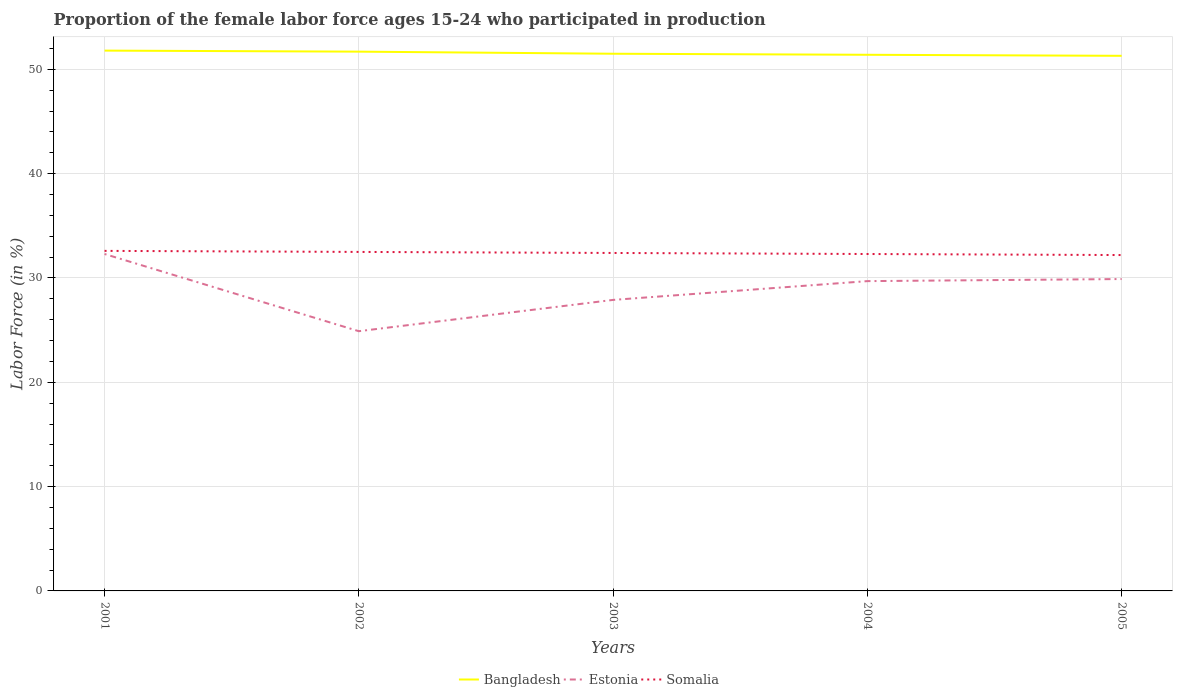How many different coloured lines are there?
Give a very brief answer. 3. Does the line corresponding to Somalia intersect with the line corresponding to Estonia?
Offer a very short reply. No. Across all years, what is the maximum proportion of the female labor force who participated in production in Bangladesh?
Provide a short and direct response. 51.3. What is the total proportion of the female labor force who participated in production in Somalia in the graph?
Make the answer very short. 0.1. What is the difference between the highest and the second highest proportion of the female labor force who participated in production in Estonia?
Provide a succinct answer. 7.4. What is the difference between two consecutive major ticks on the Y-axis?
Keep it short and to the point. 10. Are the values on the major ticks of Y-axis written in scientific E-notation?
Your response must be concise. No. Does the graph contain grids?
Your answer should be very brief. Yes. Where does the legend appear in the graph?
Make the answer very short. Bottom center. How many legend labels are there?
Give a very brief answer. 3. How are the legend labels stacked?
Offer a very short reply. Horizontal. What is the title of the graph?
Your answer should be very brief. Proportion of the female labor force ages 15-24 who participated in production. Does "Liberia" appear as one of the legend labels in the graph?
Your response must be concise. No. What is the label or title of the X-axis?
Make the answer very short. Years. What is the label or title of the Y-axis?
Offer a terse response. Labor Force (in %). What is the Labor Force (in %) of Bangladesh in 2001?
Offer a very short reply. 51.8. What is the Labor Force (in %) of Estonia in 2001?
Give a very brief answer. 32.3. What is the Labor Force (in %) in Somalia in 2001?
Make the answer very short. 32.6. What is the Labor Force (in %) of Bangladesh in 2002?
Ensure brevity in your answer.  51.7. What is the Labor Force (in %) in Estonia in 2002?
Your answer should be compact. 24.9. What is the Labor Force (in %) in Somalia in 2002?
Your response must be concise. 32.5. What is the Labor Force (in %) of Bangladesh in 2003?
Offer a terse response. 51.5. What is the Labor Force (in %) in Estonia in 2003?
Give a very brief answer. 27.9. What is the Labor Force (in %) of Somalia in 2003?
Offer a terse response. 32.4. What is the Labor Force (in %) in Bangladesh in 2004?
Provide a succinct answer. 51.4. What is the Labor Force (in %) of Estonia in 2004?
Your answer should be very brief. 29.7. What is the Labor Force (in %) in Somalia in 2004?
Give a very brief answer. 32.3. What is the Labor Force (in %) in Bangladesh in 2005?
Offer a very short reply. 51.3. What is the Labor Force (in %) of Estonia in 2005?
Your answer should be compact. 29.9. What is the Labor Force (in %) of Somalia in 2005?
Provide a short and direct response. 32.2. Across all years, what is the maximum Labor Force (in %) in Bangladesh?
Keep it short and to the point. 51.8. Across all years, what is the maximum Labor Force (in %) in Estonia?
Keep it short and to the point. 32.3. Across all years, what is the maximum Labor Force (in %) in Somalia?
Ensure brevity in your answer.  32.6. Across all years, what is the minimum Labor Force (in %) in Bangladesh?
Give a very brief answer. 51.3. Across all years, what is the minimum Labor Force (in %) of Estonia?
Your answer should be very brief. 24.9. Across all years, what is the minimum Labor Force (in %) of Somalia?
Make the answer very short. 32.2. What is the total Labor Force (in %) in Bangladesh in the graph?
Your answer should be compact. 257.7. What is the total Labor Force (in %) in Estonia in the graph?
Offer a terse response. 144.7. What is the total Labor Force (in %) in Somalia in the graph?
Offer a very short reply. 162. What is the difference between the Labor Force (in %) in Bangladesh in 2001 and that in 2002?
Your response must be concise. 0.1. What is the difference between the Labor Force (in %) in Estonia in 2001 and that in 2002?
Your response must be concise. 7.4. What is the difference between the Labor Force (in %) of Estonia in 2001 and that in 2003?
Offer a very short reply. 4.4. What is the difference between the Labor Force (in %) in Estonia in 2001 and that in 2004?
Offer a terse response. 2.6. What is the difference between the Labor Force (in %) in Somalia in 2001 and that in 2004?
Offer a terse response. 0.3. What is the difference between the Labor Force (in %) of Bangladesh in 2001 and that in 2005?
Give a very brief answer. 0.5. What is the difference between the Labor Force (in %) of Estonia in 2001 and that in 2005?
Give a very brief answer. 2.4. What is the difference between the Labor Force (in %) in Bangladesh in 2002 and that in 2003?
Make the answer very short. 0.2. What is the difference between the Labor Force (in %) of Estonia in 2002 and that in 2003?
Your answer should be very brief. -3. What is the difference between the Labor Force (in %) of Somalia in 2002 and that in 2003?
Give a very brief answer. 0.1. What is the difference between the Labor Force (in %) in Bangladesh in 2002 and that in 2004?
Provide a succinct answer. 0.3. What is the difference between the Labor Force (in %) of Somalia in 2002 and that in 2004?
Keep it short and to the point. 0.2. What is the difference between the Labor Force (in %) of Bangladesh in 2002 and that in 2005?
Provide a succinct answer. 0.4. What is the difference between the Labor Force (in %) of Estonia in 2002 and that in 2005?
Your answer should be compact. -5. What is the difference between the Labor Force (in %) of Bangladesh in 2003 and that in 2004?
Your answer should be compact. 0.1. What is the difference between the Labor Force (in %) of Somalia in 2003 and that in 2004?
Provide a succinct answer. 0.1. What is the difference between the Labor Force (in %) of Bangladesh in 2003 and that in 2005?
Keep it short and to the point. 0.2. What is the difference between the Labor Force (in %) in Somalia in 2003 and that in 2005?
Provide a succinct answer. 0.2. What is the difference between the Labor Force (in %) in Estonia in 2004 and that in 2005?
Offer a terse response. -0.2. What is the difference between the Labor Force (in %) in Bangladesh in 2001 and the Labor Force (in %) in Estonia in 2002?
Your answer should be compact. 26.9. What is the difference between the Labor Force (in %) in Bangladesh in 2001 and the Labor Force (in %) in Somalia in 2002?
Ensure brevity in your answer.  19.3. What is the difference between the Labor Force (in %) of Estonia in 2001 and the Labor Force (in %) of Somalia in 2002?
Offer a terse response. -0.2. What is the difference between the Labor Force (in %) in Bangladesh in 2001 and the Labor Force (in %) in Estonia in 2003?
Keep it short and to the point. 23.9. What is the difference between the Labor Force (in %) in Estonia in 2001 and the Labor Force (in %) in Somalia in 2003?
Your answer should be compact. -0.1. What is the difference between the Labor Force (in %) of Bangladesh in 2001 and the Labor Force (in %) of Estonia in 2004?
Give a very brief answer. 22.1. What is the difference between the Labor Force (in %) in Estonia in 2001 and the Labor Force (in %) in Somalia in 2004?
Make the answer very short. 0. What is the difference between the Labor Force (in %) of Bangladesh in 2001 and the Labor Force (in %) of Estonia in 2005?
Offer a terse response. 21.9. What is the difference between the Labor Force (in %) in Bangladesh in 2001 and the Labor Force (in %) in Somalia in 2005?
Offer a terse response. 19.6. What is the difference between the Labor Force (in %) in Estonia in 2001 and the Labor Force (in %) in Somalia in 2005?
Ensure brevity in your answer.  0.1. What is the difference between the Labor Force (in %) in Bangladesh in 2002 and the Labor Force (in %) in Estonia in 2003?
Keep it short and to the point. 23.8. What is the difference between the Labor Force (in %) of Bangladesh in 2002 and the Labor Force (in %) of Somalia in 2003?
Offer a terse response. 19.3. What is the difference between the Labor Force (in %) of Estonia in 2002 and the Labor Force (in %) of Somalia in 2003?
Offer a very short reply. -7.5. What is the difference between the Labor Force (in %) of Bangladesh in 2002 and the Labor Force (in %) of Estonia in 2004?
Your answer should be very brief. 22. What is the difference between the Labor Force (in %) of Bangladesh in 2002 and the Labor Force (in %) of Estonia in 2005?
Your response must be concise. 21.8. What is the difference between the Labor Force (in %) in Estonia in 2002 and the Labor Force (in %) in Somalia in 2005?
Ensure brevity in your answer.  -7.3. What is the difference between the Labor Force (in %) in Bangladesh in 2003 and the Labor Force (in %) in Estonia in 2004?
Your response must be concise. 21.8. What is the difference between the Labor Force (in %) in Bangladesh in 2003 and the Labor Force (in %) in Somalia in 2004?
Give a very brief answer. 19.2. What is the difference between the Labor Force (in %) of Bangladesh in 2003 and the Labor Force (in %) of Estonia in 2005?
Your response must be concise. 21.6. What is the difference between the Labor Force (in %) in Bangladesh in 2003 and the Labor Force (in %) in Somalia in 2005?
Provide a succinct answer. 19.3. What is the difference between the Labor Force (in %) in Bangladesh in 2004 and the Labor Force (in %) in Estonia in 2005?
Your answer should be compact. 21.5. What is the difference between the Labor Force (in %) in Bangladesh in 2004 and the Labor Force (in %) in Somalia in 2005?
Ensure brevity in your answer.  19.2. What is the average Labor Force (in %) of Bangladesh per year?
Provide a succinct answer. 51.54. What is the average Labor Force (in %) in Estonia per year?
Offer a very short reply. 28.94. What is the average Labor Force (in %) of Somalia per year?
Ensure brevity in your answer.  32.4. In the year 2001, what is the difference between the Labor Force (in %) of Estonia and Labor Force (in %) of Somalia?
Your response must be concise. -0.3. In the year 2002, what is the difference between the Labor Force (in %) of Bangladesh and Labor Force (in %) of Estonia?
Your response must be concise. 26.8. In the year 2002, what is the difference between the Labor Force (in %) of Estonia and Labor Force (in %) of Somalia?
Offer a terse response. -7.6. In the year 2003, what is the difference between the Labor Force (in %) of Bangladesh and Labor Force (in %) of Estonia?
Give a very brief answer. 23.6. In the year 2003, what is the difference between the Labor Force (in %) in Estonia and Labor Force (in %) in Somalia?
Provide a succinct answer. -4.5. In the year 2004, what is the difference between the Labor Force (in %) in Bangladesh and Labor Force (in %) in Estonia?
Your answer should be compact. 21.7. In the year 2004, what is the difference between the Labor Force (in %) of Bangladesh and Labor Force (in %) of Somalia?
Make the answer very short. 19.1. In the year 2004, what is the difference between the Labor Force (in %) in Estonia and Labor Force (in %) in Somalia?
Keep it short and to the point. -2.6. In the year 2005, what is the difference between the Labor Force (in %) in Bangladesh and Labor Force (in %) in Estonia?
Your response must be concise. 21.4. What is the ratio of the Labor Force (in %) of Bangladesh in 2001 to that in 2002?
Provide a succinct answer. 1. What is the ratio of the Labor Force (in %) of Estonia in 2001 to that in 2002?
Keep it short and to the point. 1.3. What is the ratio of the Labor Force (in %) of Bangladesh in 2001 to that in 2003?
Keep it short and to the point. 1.01. What is the ratio of the Labor Force (in %) in Estonia in 2001 to that in 2003?
Your answer should be compact. 1.16. What is the ratio of the Labor Force (in %) in Bangladesh in 2001 to that in 2004?
Provide a short and direct response. 1.01. What is the ratio of the Labor Force (in %) of Estonia in 2001 to that in 2004?
Make the answer very short. 1.09. What is the ratio of the Labor Force (in %) in Somalia in 2001 to that in 2004?
Your answer should be compact. 1.01. What is the ratio of the Labor Force (in %) in Bangladesh in 2001 to that in 2005?
Give a very brief answer. 1.01. What is the ratio of the Labor Force (in %) in Estonia in 2001 to that in 2005?
Ensure brevity in your answer.  1.08. What is the ratio of the Labor Force (in %) of Somalia in 2001 to that in 2005?
Your response must be concise. 1.01. What is the ratio of the Labor Force (in %) of Bangladesh in 2002 to that in 2003?
Give a very brief answer. 1. What is the ratio of the Labor Force (in %) in Estonia in 2002 to that in 2003?
Provide a short and direct response. 0.89. What is the ratio of the Labor Force (in %) of Somalia in 2002 to that in 2003?
Your answer should be compact. 1. What is the ratio of the Labor Force (in %) of Estonia in 2002 to that in 2004?
Ensure brevity in your answer.  0.84. What is the ratio of the Labor Force (in %) of Bangladesh in 2002 to that in 2005?
Provide a succinct answer. 1.01. What is the ratio of the Labor Force (in %) of Estonia in 2002 to that in 2005?
Ensure brevity in your answer.  0.83. What is the ratio of the Labor Force (in %) in Somalia in 2002 to that in 2005?
Offer a terse response. 1.01. What is the ratio of the Labor Force (in %) in Bangladesh in 2003 to that in 2004?
Keep it short and to the point. 1. What is the ratio of the Labor Force (in %) in Estonia in 2003 to that in 2004?
Give a very brief answer. 0.94. What is the ratio of the Labor Force (in %) in Bangladesh in 2003 to that in 2005?
Make the answer very short. 1. What is the ratio of the Labor Force (in %) in Estonia in 2003 to that in 2005?
Your answer should be compact. 0.93. What is the ratio of the Labor Force (in %) in Somalia in 2003 to that in 2005?
Ensure brevity in your answer.  1.01. What is the ratio of the Labor Force (in %) in Somalia in 2004 to that in 2005?
Offer a very short reply. 1. What is the difference between the highest and the lowest Labor Force (in %) in Somalia?
Offer a terse response. 0.4. 